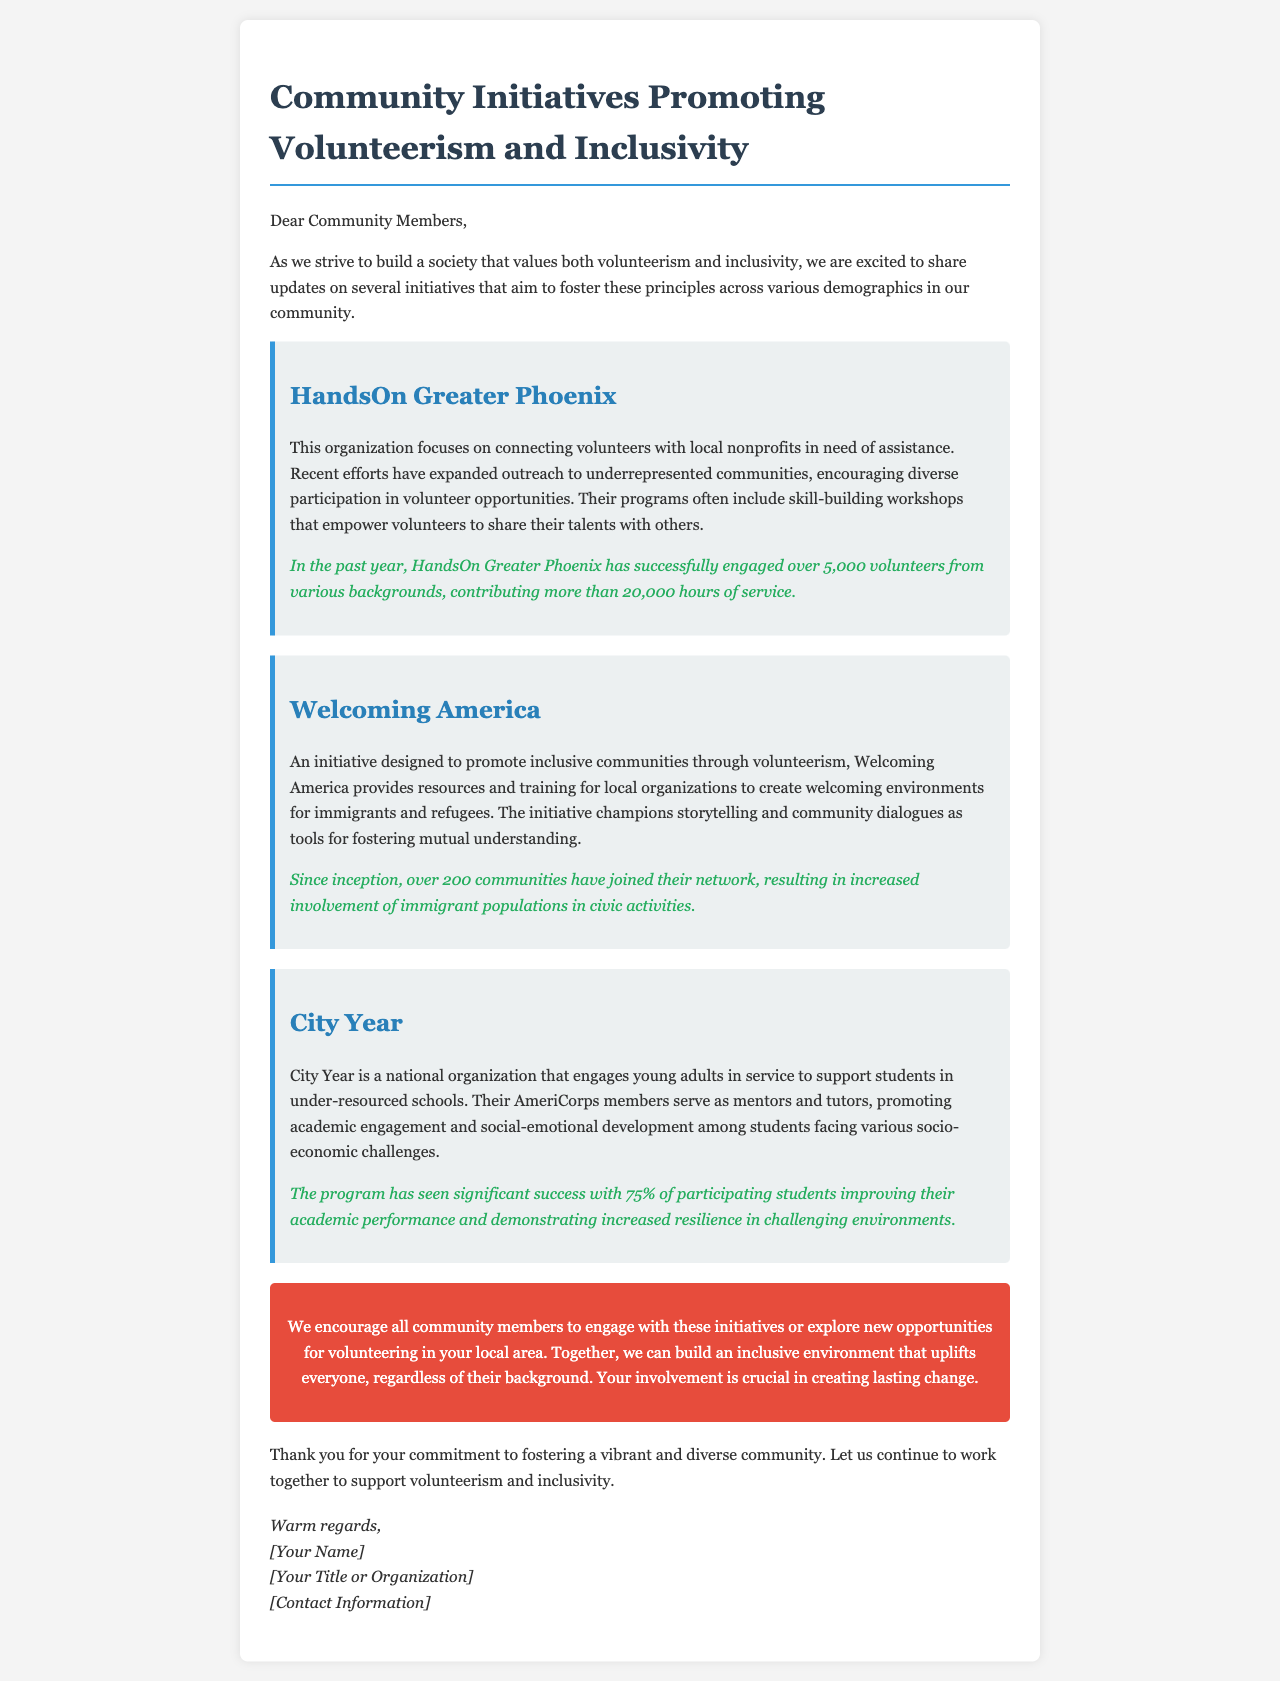What is the title of the newsletter? The title of the newsletter is provided at the top of the letter, indicating its focus on community initiatives.
Answer: Community Initiatives Promoting Volunteerism and Inclusivity How many volunteers did HandsOn Greater Phoenix engage in the past year? The document states the number of volunteers engaged by HandsOn Greater Phoenix in the past year.
Answer: over 5,000 volunteers What is the main focus of the initiative Welcoming America? The focus of Welcoming America is mentioned in the letter as it promotes inclusive communities.
Answer: inclusive communities What percentage of students improved their academic performance in the City Year program? The document provides a statistic regarding the success of students participating in the City Year program.
Answer: 75% What is encouraged for community members in the call-to-action section? The call-to-action section urges community members to engage with certain initiatives mentioned in the letter.
Answer: engage with these initiatives What type of environment does Welcoming America aim to create? The document describes the kind of environment that Welcoming America helps to foster for specific groups in the community.
Answer: welcoming environments Which organization connects volunteers with local nonprofits? The letter indicates an organization dedicated to connecting volunteers with nonprofits for assistance.
Answer: HandsOn Greater Phoenix 